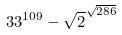<formula> <loc_0><loc_0><loc_500><loc_500>3 3 ^ { 1 0 9 } - \sqrt { 2 } ^ { \sqrt { 2 8 6 } }</formula> 